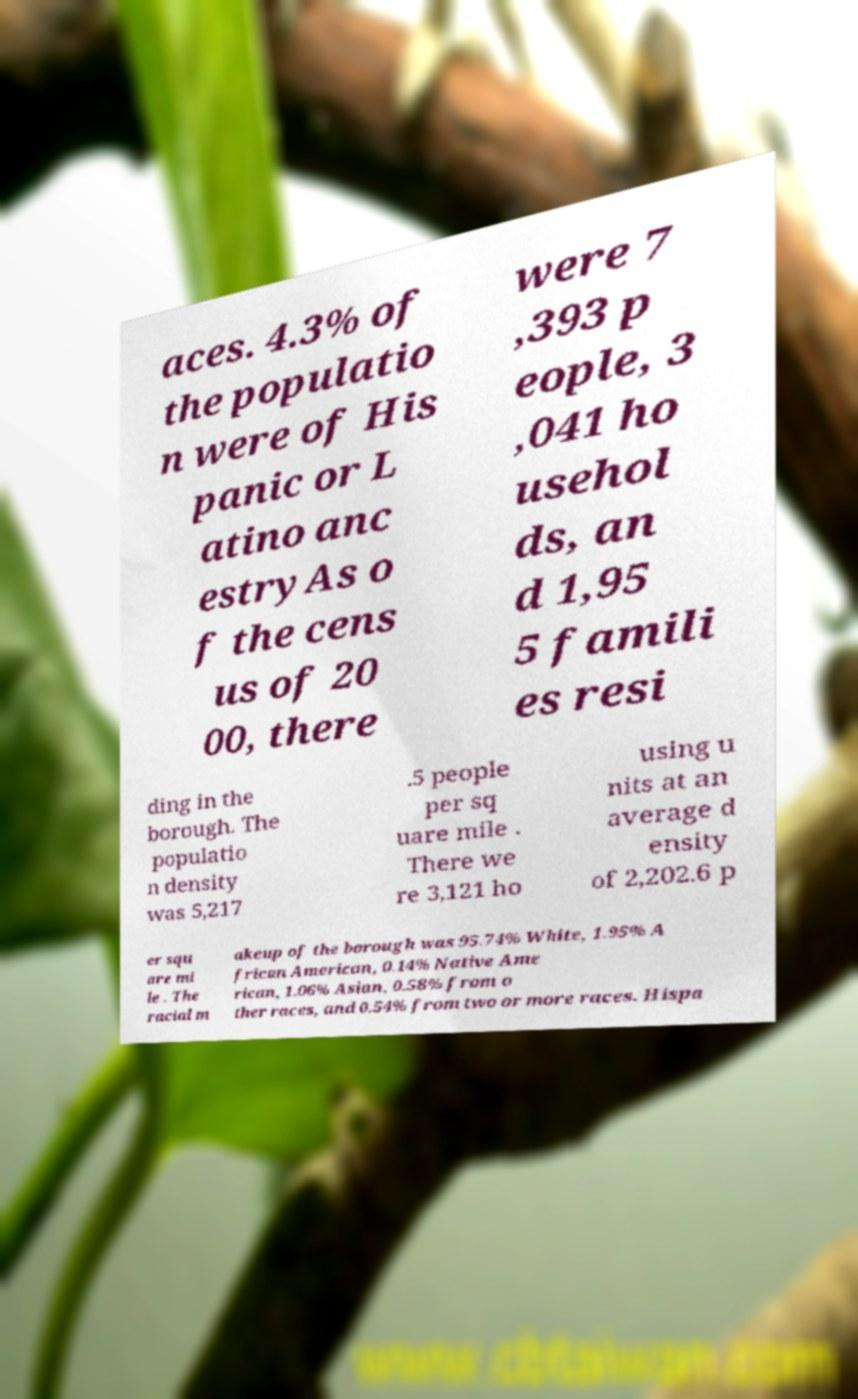What messages or text are displayed in this image? I need them in a readable, typed format. aces. 4.3% of the populatio n were of His panic or L atino anc estryAs o f the cens us of 20 00, there were 7 ,393 p eople, 3 ,041 ho usehol ds, an d 1,95 5 famili es resi ding in the borough. The populatio n density was 5,217 .5 people per sq uare mile . There we re 3,121 ho using u nits at an average d ensity of 2,202.6 p er squ are mi le . The racial m akeup of the borough was 95.74% White, 1.95% A frican American, 0.14% Native Ame rican, 1.06% Asian, 0.58% from o ther races, and 0.54% from two or more races. Hispa 